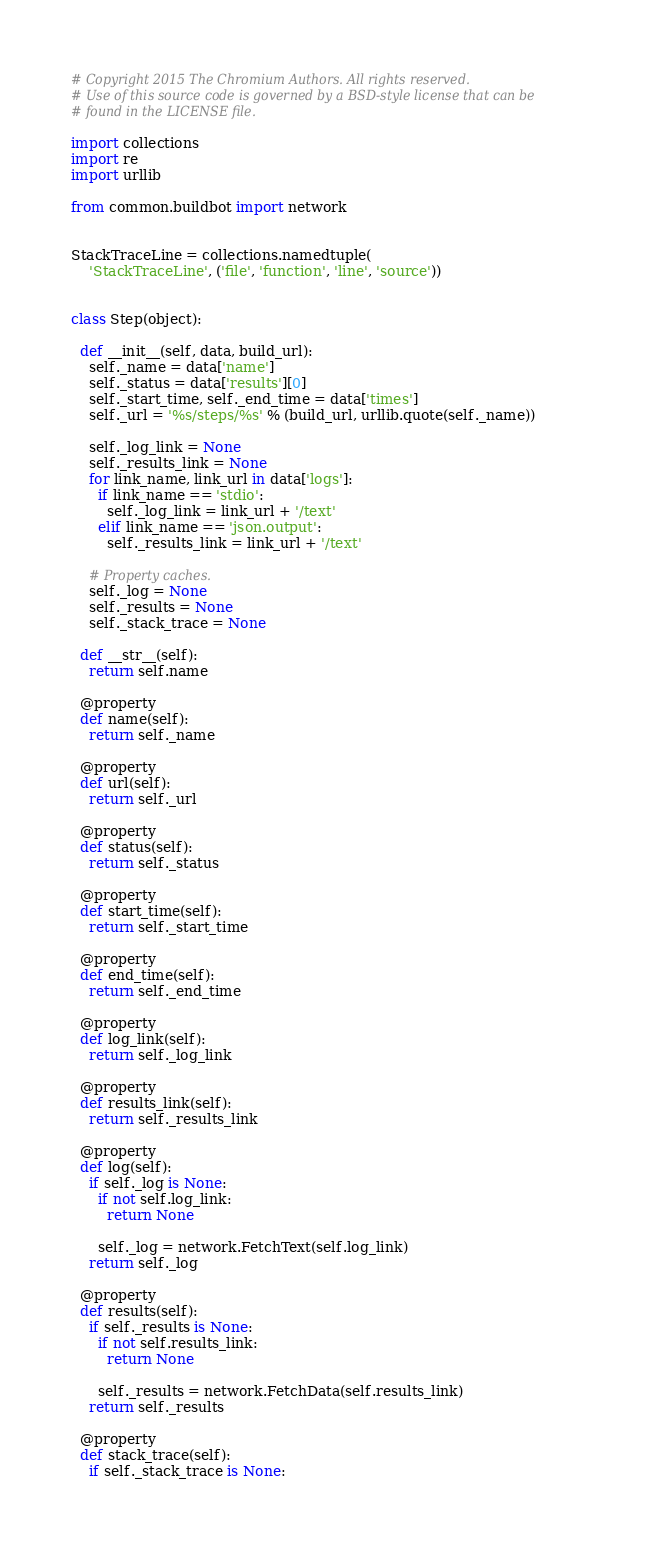<code> <loc_0><loc_0><loc_500><loc_500><_Python_># Copyright 2015 The Chromium Authors. All rights reserved.
# Use of this source code is governed by a BSD-style license that can be
# found in the LICENSE file.

import collections
import re
import urllib

from common.buildbot import network


StackTraceLine = collections.namedtuple(
    'StackTraceLine', ('file', 'function', 'line', 'source'))


class Step(object):

  def __init__(self, data, build_url):
    self._name = data['name']
    self._status = data['results'][0]
    self._start_time, self._end_time = data['times']
    self._url = '%s/steps/%s' % (build_url, urllib.quote(self._name))

    self._log_link = None
    self._results_link = None
    for link_name, link_url in data['logs']:
      if link_name == 'stdio':
        self._log_link = link_url + '/text'
      elif link_name == 'json.output':
        self._results_link = link_url + '/text'

    # Property caches.
    self._log = None
    self._results = None
    self._stack_trace = None

  def __str__(self):
    return self.name

  @property
  def name(self):
    return self._name

  @property
  def url(self):
    return self._url

  @property
  def status(self):
    return self._status

  @property
  def start_time(self):
    return self._start_time

  @property
  def end_time(self):
    return self._end_time

  @property
  def log_link(self):
    return self._log_link

  @property
  def results_link(self):
    return self._results_link

  @property
  def log(self):
    if self._log is None:
      if not self.log_link:
        return None

      self._log = network.FetchText(self.log_link)
    return self._log

  @property
  def results(self):
    if self._results is None:
      if not self.results_link:
        return None

      self._results = network.FetchData(self.results_link)
    return self._results

  @property
  def stack_trace(self):
    if self._stack_trace is None:</code> 